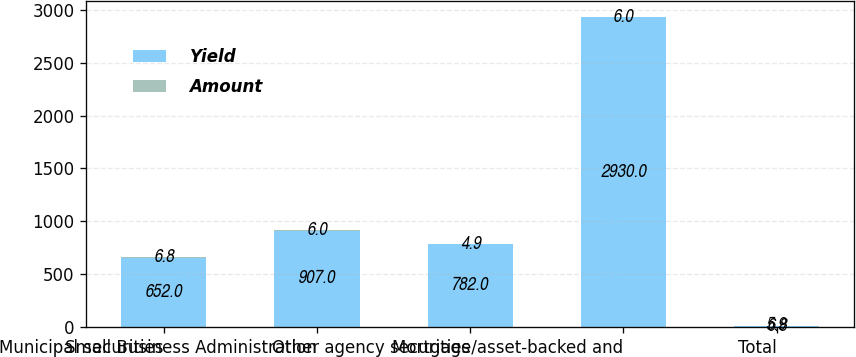<chart> <loc_0><loc_0><loc_500><loc_500><stacked_bar_chart><ecel><fcel>Municipal securities<fcel>Small Business Administration<fcel>Other agency securities<fcel>Mortgage/asset-backed and<fcel>Total<nl><fcel>Yield<fcel>652<fcel>907<fcel>782<fcel>2930<fcel>6.8<nl><fcel>Amount<fcel>6.8<fcel>6<fcel>4.9<fcel>6<fcel>5.9<nl></chart> 